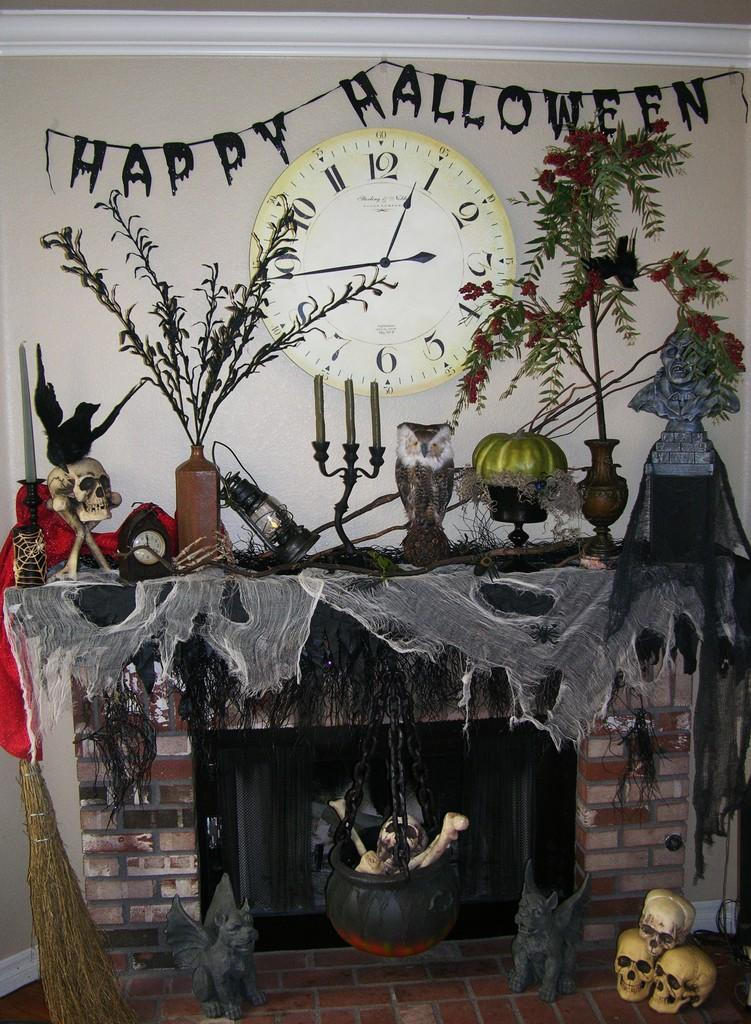<image>
Summarize the visual content of the image. A Halloween sign is hanging above a fire place. 